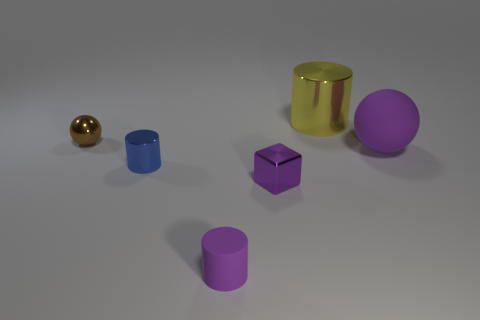Add 3 purple shiny blocks. How many objects exist? 9 Subtract all cubes. How many objects are left? 5 Subtract 0 brown cubes. How many objects are left? 6 Subtract all brown shiny balls. Subtract all small purple rubber cylinders. How many objects are left? 4 Add 6 small metal cylinders. How many small metal cylinders are left? 7 Add 6 large green things. How many large green things exist? 6 